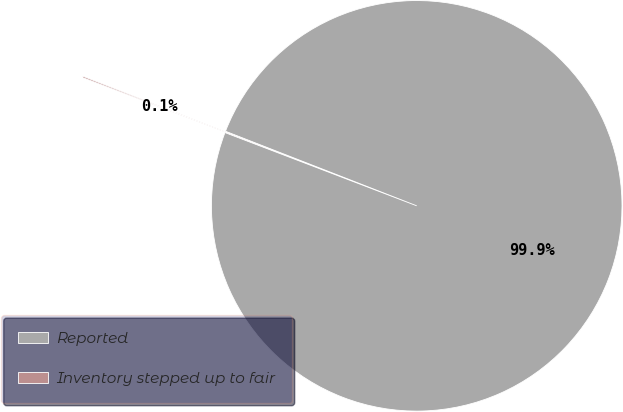<chart> <loc_0><loc_0><loc_500><loc_500><pie_chart><fcel>Reported<fcel>Inventory stepped up to fair<nl><fcel>99.89%<fcel>0.11%<nl></chart> 